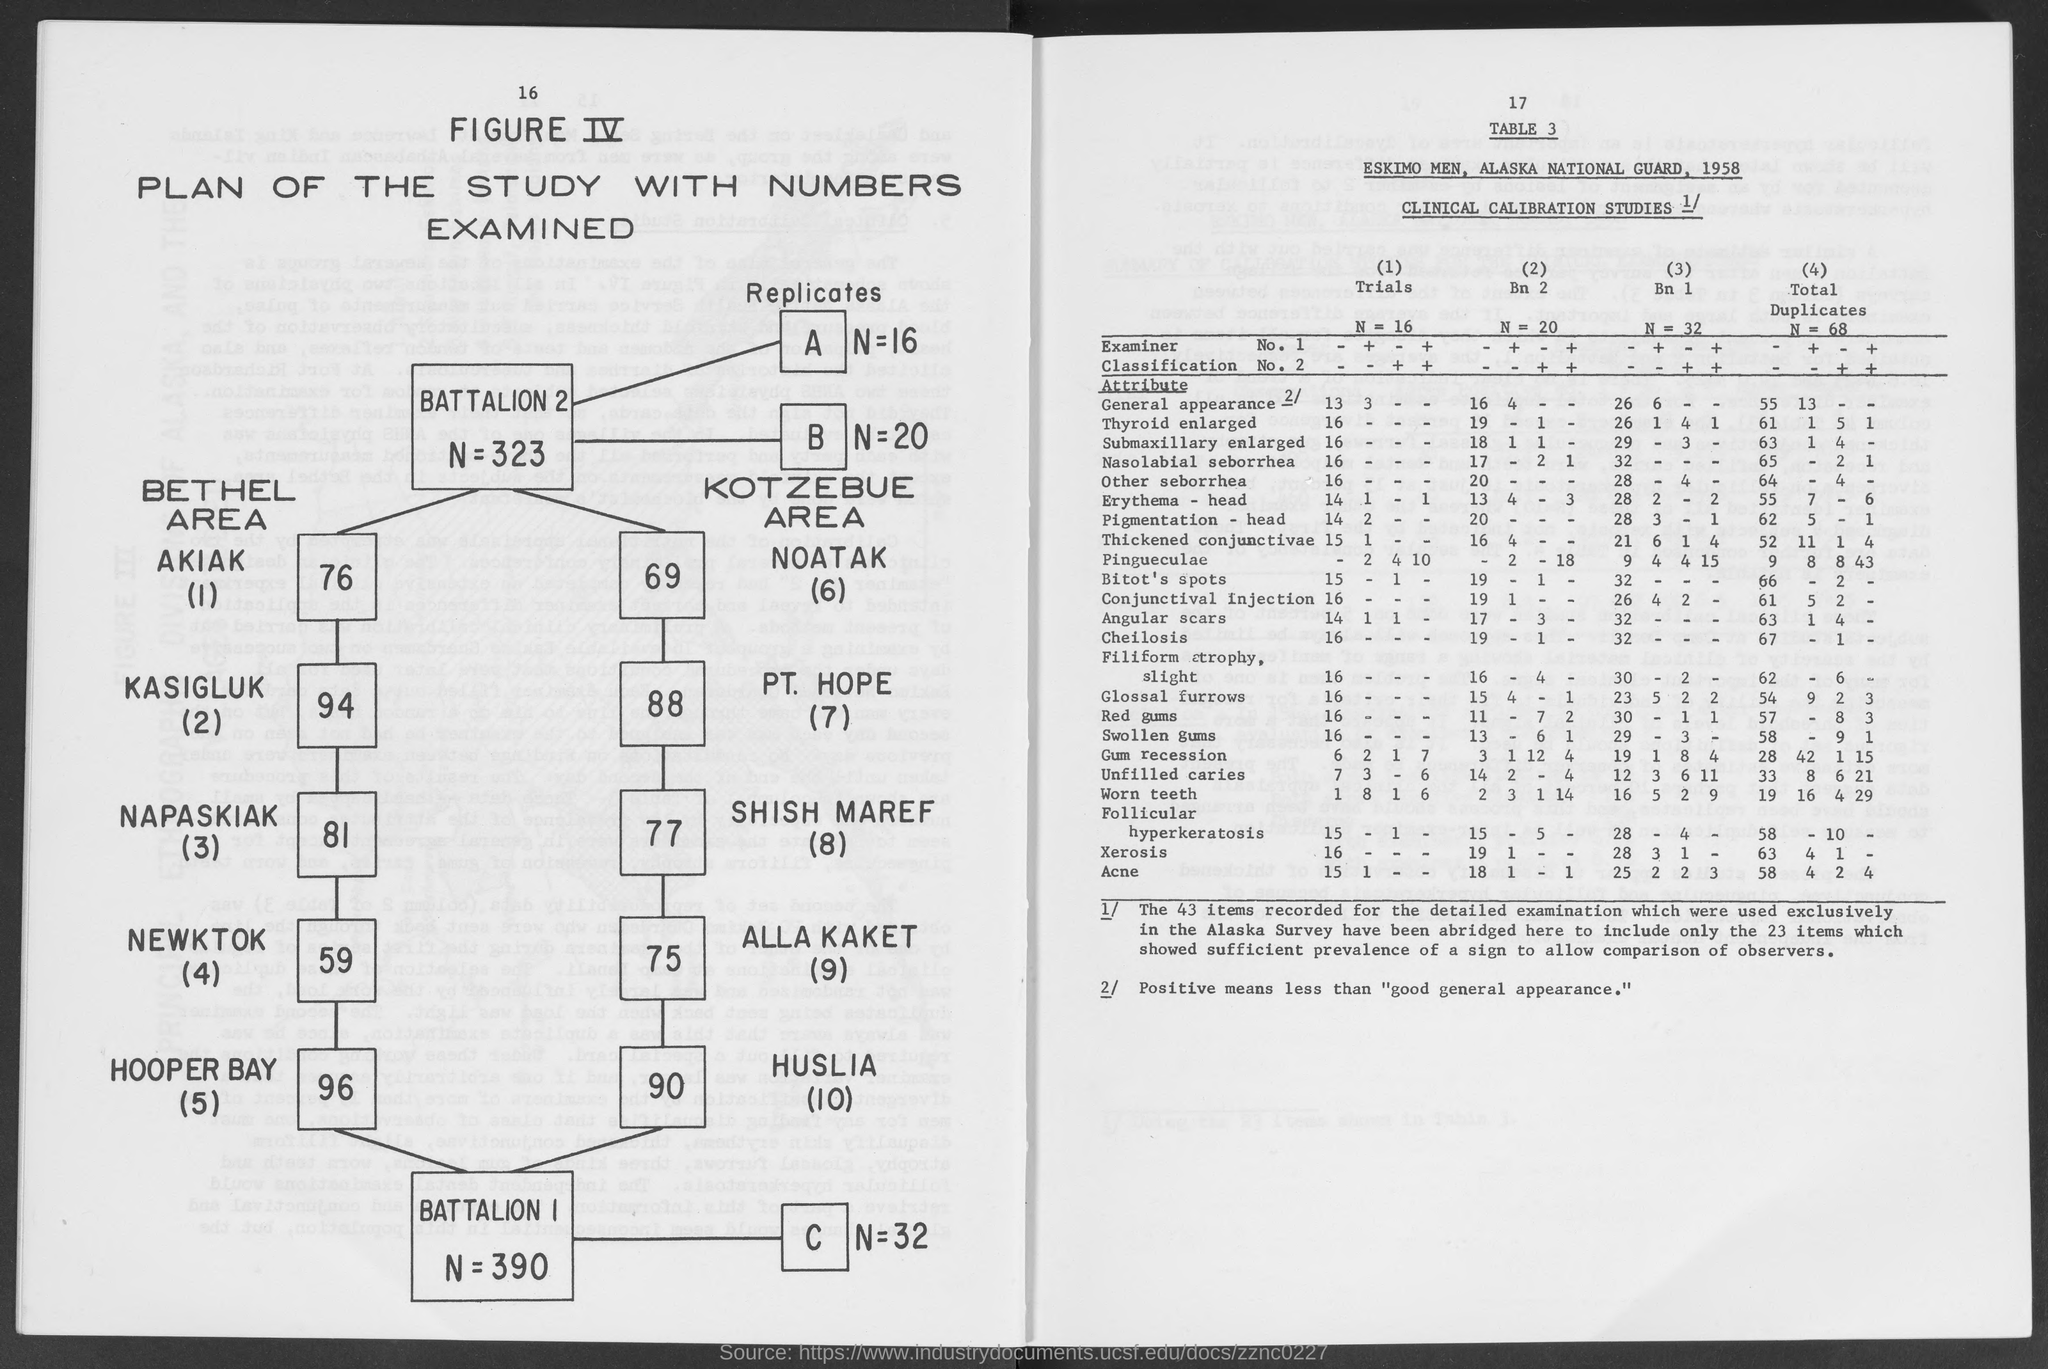Positive means less than what?
Offer a very short reply. "good general appearance.". 